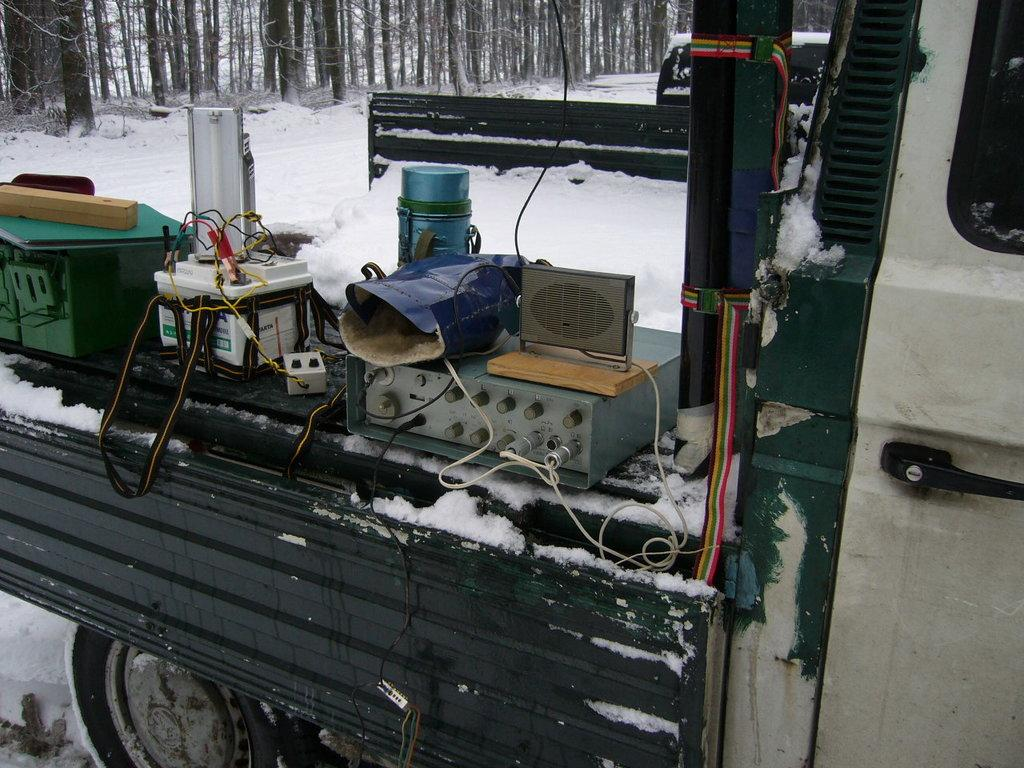What is the main subject of the image? The main subject of the image is a truck. What else can be seen in the image besides the truck? Electrical equipment is present in the image. What is the weather like in the image? There is snow visible in the image, indicating a cold or wintery environment. What can be seen in the background of the image? There are trees in the background of the image. What type of mint is growing on the truck in the image? There is no mint plant visible on the truck in the image. 